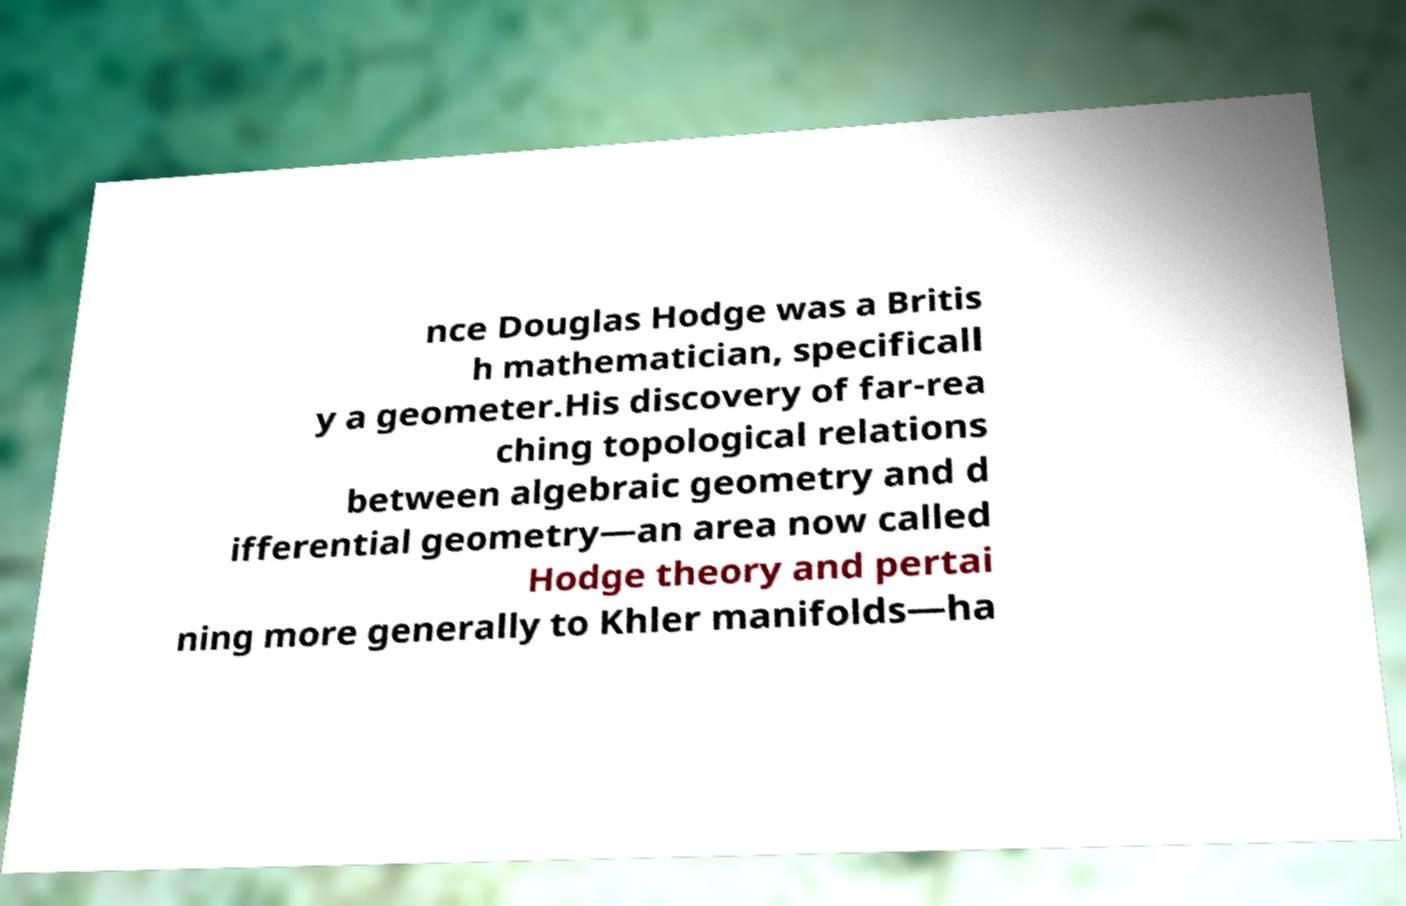Could you extract and type out the text from this image? nce Douglas Hodge was a Britis h mathematician, specificall y a geometer.His discovery of far-rea ching topological relations between algebraic geometry and d ifferential geometry—an area now called Hodge theory and pertai ning more generally to Khler manifolds—ha 